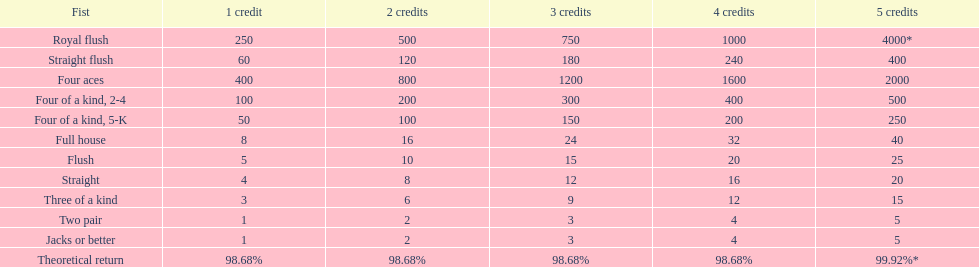The number of credits returned for a one credit bet on a royal flush are. 250. 